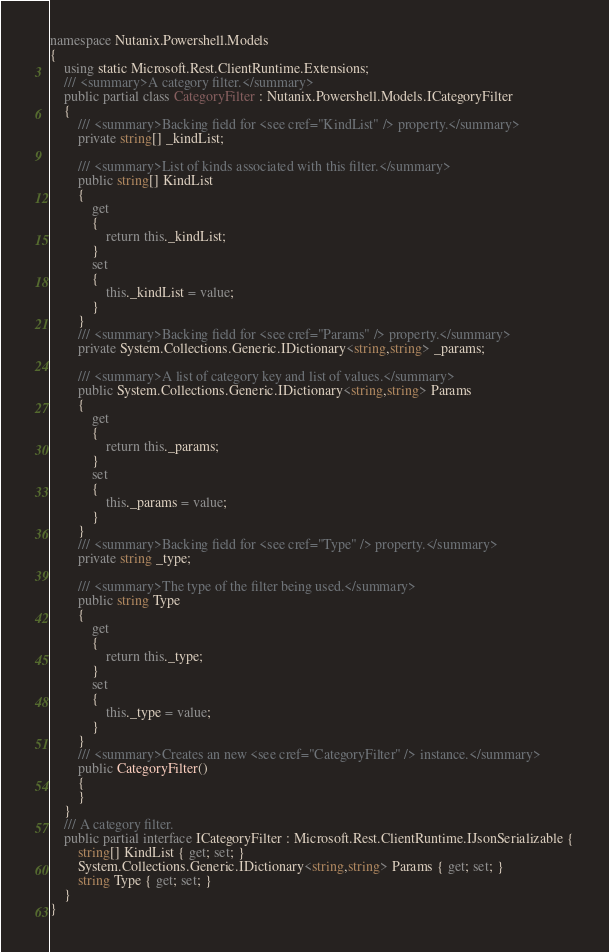Convert code to text. <code><loc_0><loc_0><loc_500><loc_500><_C#_>namespace Nutanix.Powershell.Models
{
    using static Microsoft.Rest.ClientRuntime.Extensions;
    /// <summary>A category filter.</summary>
    public partial class CategoryFilter : Nutanix.Powershell.Models.ICategoryFilter
    {
        /// <summary>Backing field for <see cref="KindList" /> property.</summary>
        private string[] _kindList;

        /// <summary>List of kinds associated with this filter.</summary>
        public string[] KindList
        {
            get
            {
                return this._kindList;
            }
            set
            {
                this._kindList = value;
            }
        }
        /// <summary>Backing field for <see cref="Params" /> property.</summary>
        private System.Collections.Generic.IDictionary<string,string> _params;

        /// <summary>A list of category key and list of values.</summary>
        public System.Collections.Generic.IDictionary<string,string> Params
        {
            get
            {
                return this._params;
            }
            set
            {
                this._params = value;
            }
        }
        /// <summary>Backing field for <see cref="Type" /> property.</summary>
        private string _type;

        /// <summary>The type of the filter being used.</summary>
        public string Type
        {
            get
            {
                return this._type;
            }
            set
            {
                this._type = value;
            }
        }
        /// <summary>Creates an new <see cref="CategoryFilter" /> instance.</summary>
        public CategoryFilter()
        {
        }
    }
    /// A category filter.
    public partial interface ICategoryFilter : Microsoft.Rest.ClientRuntime.IJsonSerializable {
        string[] KindList { get; set; }
        System.Collections.Generic.IDictionary<string,string> Params { get; set; }
        string Type { get; set; }
    }
}</code> 